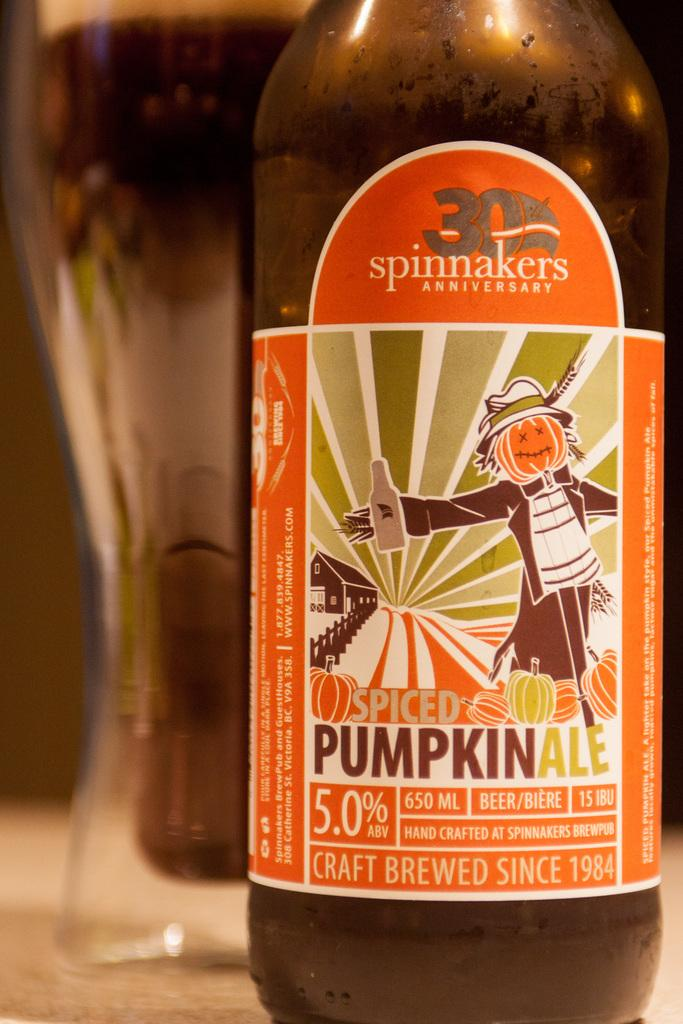<image>
Offer a succinct explanation of the picture presented. A glass bottle of spinnakers spiced pumpkin ale 